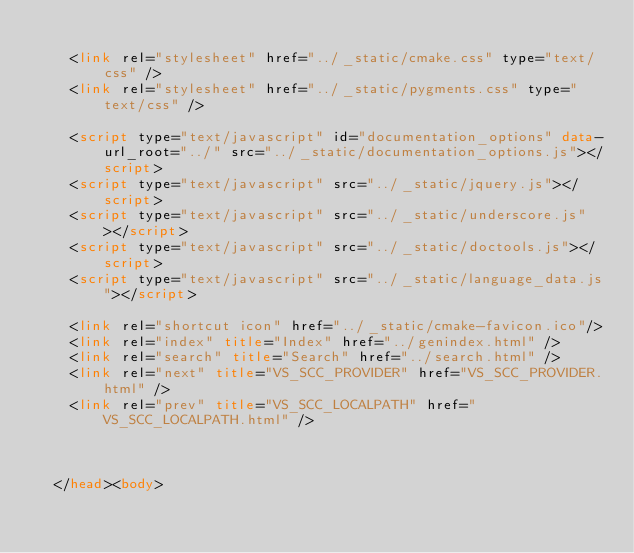<code> <loc_0><loc_0><loc_500><loc_500><_HTML_>
    <link rel="stylesheet" href="../_static/cmake.css" type="text/css" />
    <link rel="stylesheet" href="../_static/pygments.css" type="text/css" />
    
    <script type="text/javascript" id="documentation_options" data-url_root="../" src="../_static/documentation_options.js"></script>
    <script type="text/javascript" src="../_static/jquery.js"></script>
    <script type="text/javascript" src="../_static/underscore.js"></script>
    <script type="text/javascript" src="../_static/doctools.js"></script>
    <script type="text/javascript" src="../_static/language_data.js"></script>
    
    <link rel="shortcut icon" href="../_static/cmake-favicon.ico"/>
    <link rel="index" title="Index" href="../genindex.html" />
    <link rel="search" title="Search" href="../search.html" />
    <link rel="next" title="VS_SCC_PROVIDER" href="VS_SCC_PROVIDER.html" />
    <link rel="prev" title="VS_SCC_LOCALPATH" href="VS_SCC_LOCALPATH.html" />
  
 

  </head><body></code> 